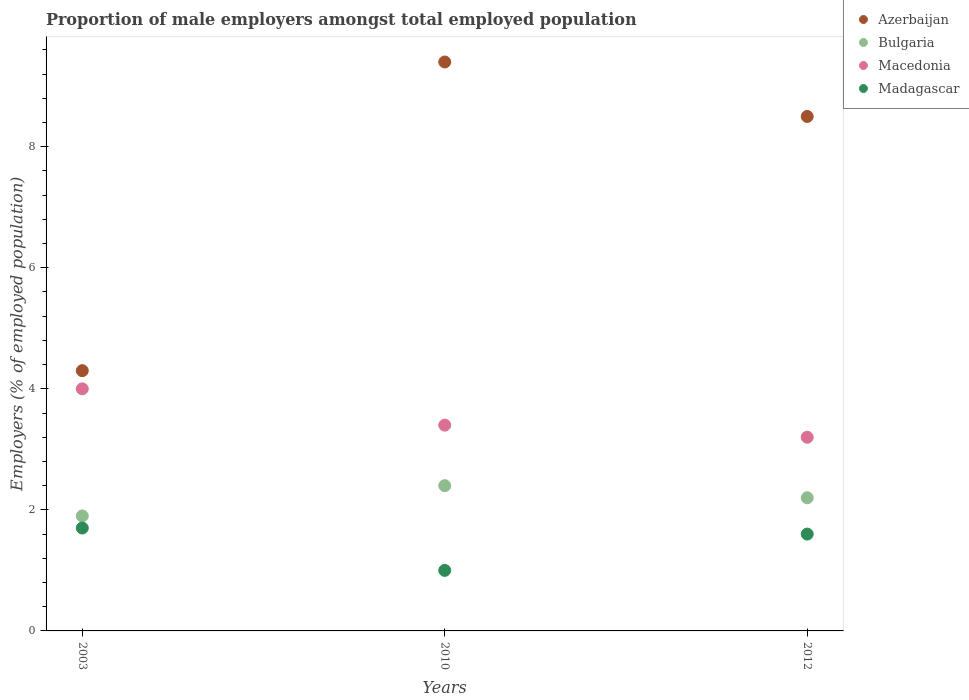How many different coloured dotlines are there?
Your answer should be very brief. 4. Is the number of dotlines equal to the number of legend labels?
Give a very brief answer. Yes. Across all years, what is the maximum proportion of male employers in Macedonia?
Your answer should be very brief. 4. Across all years, what is the minimum proportion of male employers in Bulgaria?
Provide a short and direct response. 1.9. What is the total proportion of male employers in Azerbaijan in the graph?
Keep it short and to the point. 22.2. What is the difference between the proportion of male employers in Madagascar in 2010 and that in 2012?
Your answer should be compact. -0.6. What is the difference between the proportion of male employers in Azerbaijan in 2003 and the proportion of male employers in Madagascar in 2012?
Your response must be concise. 2.7. What is the average proportion of male employers in Madagascar per year?
Offer a very short reply. 1.43. In the year 2003, what is the difference between the proportion of male employers in Bulgaria and proportion of male employers in Macedonia?
Provide a succinct answer. -2.1. What is the ratio of the proportion of male employers in Madagascar in 2003 to that in 2012?
Offer a terse response. 1.06. Is the proportion of male employers in Bulgaria in 2010 less than that in 2012?
Your response must be concise. No. What is the difference between the highest and the second highest proportion of male employers in Azerbaijan?
Give a very brief answer. 0.9. What is the difference between the highest and the lowest proportion of male employers in Azerbaijan?
Your answer should be very brief. 5.1. Does the proportion of male employers in Macedonia monotonically increase over the years?
Keep it short and to the point. No. Is the proportion of male employers in Azerbaijan strictly greater than the proportion of male employers in Macedonia over the years?
Your response must be concise. Yes. Is the proportion of male employers in Bulgaria strictly less than the proportion of male employers in Macedonia over the years?
Your response must be concise. Yes. How many dotlines are there?
Offer a very short reply. 4. How many years are there in the graph?
Keep it short and to the point. 3. What is the difference between two consecutive major ticks on the Y-axis?
Your answer should be compact. 2. Does the graph contain any zero values?
Your answer should be very brief. No. What is the title of the graph?
Offer a very short reply. Proportion of male employers amongst total employed population. Does "Monaco" appear as one of the legend labels in the graph?
Your answer should be very brief. No. What is the label or title of the Y-axis?
Your response must be concise. Employers (% of employed population). What is the Employers (% of employed population) of Azerbaijan in 2003?
Your answer should be very brief. 4.3. What is the Employers (% of employed population) in Bulgaria in 2003?
Your response must be concise. 1.9. What is the Employers (% of employed population) of Macedonia in 2003?
Offer a terse response. 4. What is the Employers (% of employed population) in Madagascar in 2003?
Offer a terse response. 1.7. What is the Employers (% of employed population) in Azerbaijan in 2010?
Provide a succinct answer. 9.4. What is the Employers (% of employed population) in Bulgaria in 2010?
Give a very brief answer. 2.4. What is the Employers (% of employed population) in Macedonia in 2010?
Your answer should be compact. 3.4. What is the Employers (% of employed population) in Madagascar in 2010?
Offer a terse response. 1. What is the Employers (% of employed population) of Bulgaria in 2012?
Keep it short and to the point. 2.2. What is the Employers (% of employed population) in Macedonia in 2012?
Your answer should be compact. 3.2. What is the Employers (% of employed population) of Madagascar in 2012?
Your answer should be compact. 1.6. Across all years, what is the maximum Employers (% of employed population) of Azerbaijan?
Make the answer very short. 9.4. Across all years, what is the maximum Employers (% of employed population) in Bulgaria?
Ensure brevity in your answer.  2.4. Across all years, what is the maximum Employers (% of employed population) of Macedonia?
Your response must be concise. 4. Across all years, what is the maximum Employers (% of employed population) of Madagascar?
Give a very brief answer. 1.7. Across all years, what is the minimum Employers (% of employed population) of Azerbaijan?
Your answer should be very brief. 4.3. Across all years, what is the minimum Employers (% of employed population) of Bulgaria?
Provide a succinct answer. 1.9. Across all years, what is the minimum Employers (% of employed population) in Macedonia?
Keep it short and to the point. 3.2. Across all years, what is the minimum Employers (% of employed population) of Madagascar?
Provide a succinct answer. 1. What is the total Employers (% of employed population) in Azerbaijan in the graph?
Offer a terse response. 22.2. What is the total Employers (% of employed population) in Macedonia in the graph?
Keep it short and to the point. 10.6. What is the total Employers (% of employed population) in Madagascar in the graph?
Provide a short and direct response. 4.3. What is the difference between the Employers (% of employed population) in Azerbaijan in 2003 and that in 2010?
Offer a very short reply. -5.1. What is the difference between the Employers (% of employed population) in Madagascar in 2003 and that in 2010?
Your answer should be compact. 0.7. What is the difference between the Employers (% of employed population) in Bulgaria in 2003 and that in 2012?
Keep it short and to the point. -0.3. What is the difference between the Employers (% of employed population) in Macedonia in 2003 and that in 2012?
Give a very brief answer. 0.8. What is the difference between the Employers (% of employed population) in Madagascar in 2003 and that in 2012?
Offer a terse response. 0.1. What is the difference between the Employers (% of employed population) of Bulgaria in 2010 and that in 2012?
Provide a succinct answer. 0.2. What is the difference between the Employers (% of employed population) of Macedonia in 2010 and that in 2012?
Your response must be concise. 0.2. What is the difference between the Employers (% of employed population) of Madagascar in 2010 and that in 2012?
Make the answer very short. -0.6. What is the difference between the Employers (% of employed population) in Azerbaijan in 2003 and the Employers (% of employed population) in Bulgaria in 2010?
Provide a short and direct response. 1.9. What is the difference between the Employers (% of employed population) in Bulgaria in 2003 and the Employers (% of employed population) in Macedonia in 2010?
Provide a short and direct response. -1.5. What is the difference between the Employers (% of employed population) of Macedonia in 2003 and the Employers (% of employed population) of Madagascar in 2010?
Keep it short and to the point. 3. What is the difference between the Employers (% of employed population) of Azerbaijan in 2003 and the Employers (% of employed population) of Bulgaria in 2012?
Ensure brevity in your answer.  2.1. What is the difference between the Employers (% of employed population) of Azerbaijan in 2010 and the Employers (% of employed population) of Bulgaria in 2012?
Your answer should be very brief. 7.2. What is the difference between the Employers (% of employed population) of Azerbaijan in 2010 and the Employers (% of employed population) of Macedonia in 2012?
Make the answer very short. 6.2. What is the average Employers (% of employed population) of Azerbaijan per year?
Keep it short and to the point. 7.4. What is the average Employers (% of employed population) in Bulgaria per year?
Provide a short and direct response. 2.17. What is the average Employers (% of employed population) of Macedonia per year?
Give a very brief answer. 3.53. What is the average Employers (% of employed population) of Madagascar per year?
Provide a succinct answer. 1.43. In the year 2003, what is the difference between the Employers (% of employed population) in Azerbaijan and Employers (% of employed population) in Macedonia?
Keep it short and to the point. 0.3. In the year 2003, what is the difference between the Employers (% of employed population) of Azerbaijan and Employers (% of employed population) of Madagascar?
Your answer should be compact. 2.6. In the year 2003, what is the difference between the Employers (% of employed population) of Macedonia and Employers (% of employed population) of Madagascar?
Keep it short and to the point. 2.3. In the year 2010, what is the difference between the Employers (% of employed population) of Azerbaijan and Employers (% of employed population) of Macedonia?
Ensure brevity in your answer.  6. In the year 2010, what is the difference between the Employers (% of employed population) in Bulgaria and Employers (% of employed population) in Macedonia?
Ensure brevity in your answer.  -1. In the year 2012, what is the difference between the Employers (% of employed population) of Azerbaijan and Employers (% of employed population) of Bulgaria?
Give a very brief answer. 6.3. What is the ratio of the Employers (% of employed population) in Azerbaijan in 2003 to that in 2010?
Keep it short and to the point. 0.46. What is the ratio of the Employers (% of employed population) of Bulgaria in 2003 to that in 2010?
Provide a succinct answer. 0.79. What is the ratio of the Employers (% of employed population) of Macedonia in 2003 to that in 2010?
Provide a short and direct response. 1.18. What is the ratio of the Employers (% of employed population) in Madagascar in 2003 to that in 2010?
Your answer should be compact. 1.7. What is the ratio of the Employers (% of employed population) of Azerbaijan in 2003 to that in 2012?
Provide a succinct answer. 0.51. What is the ratio of the Employers (% of employed population) of Bulgaria in 2003 to that in 2012?
Your response must be concise. 0.86. What is the ratio of the Employers (% of employed population) of Azerbaijan in 2010 to that in 2012?
Provide a succinct answer. 1.11. What is the difference between the highest and the second highest Employers (% of employed population) in Azerbaijan?
Give a very brief answer. 0.9. What is the difference between the highest and the second highest Employers (% of employed population) in Bulgaria?
Keep it short and to the point. 0.2. What is the difference between the highest and the second highest Employers (% of employed population) in Madagascar?
Your answer should be compact. 0.1. What is the difference between the highest and the lowest Employers (% of employed population) in Azerbaijan?
Give a very brief answer. 5.1. What is the difference between the highest and the lowest Employers (% of employed population) in Bulgaria?
Offer a terse response. 0.5. What is the difference between the highest and the lowest Employers (% of employed population) of Madagascar?
Your response must be concise. 0.7. 